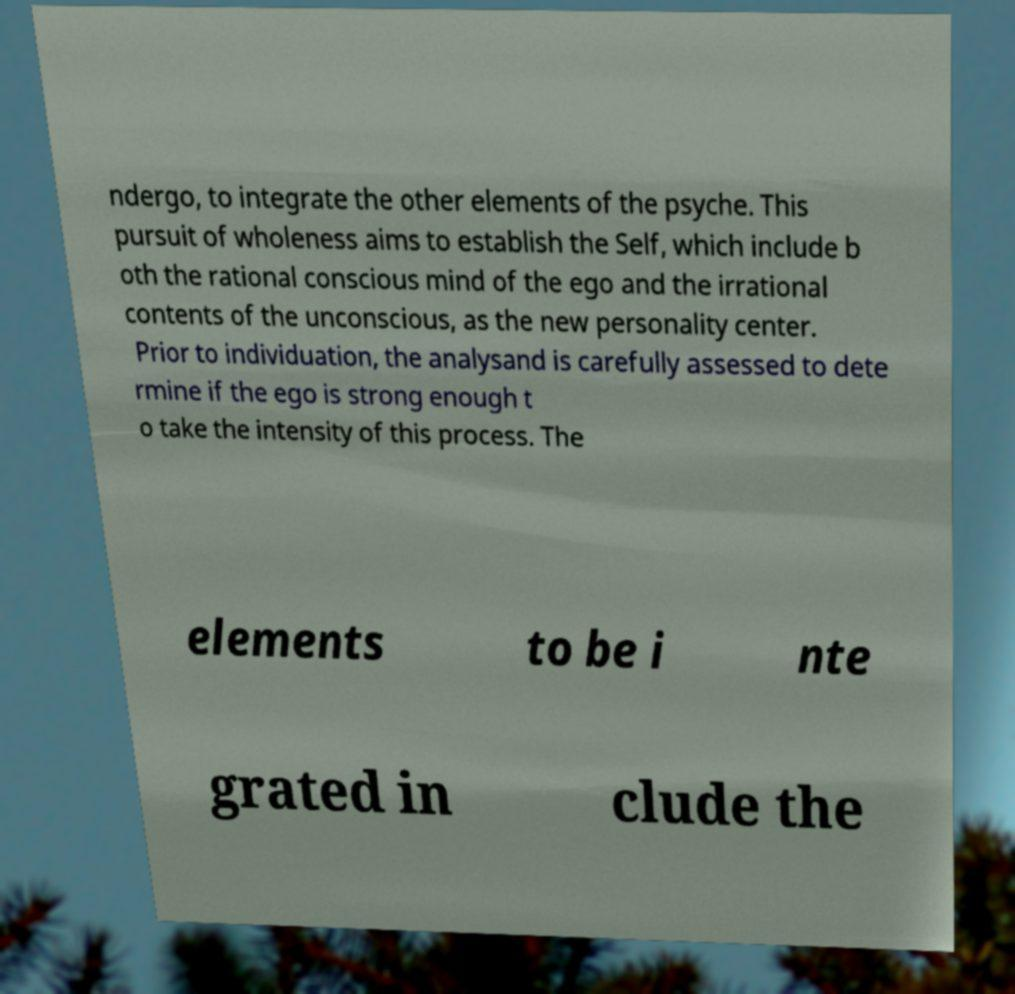Could you assist in decoding the text presented in this image and type it out clearly? ndergo, to integrate the other elements of the psyche. This pursuit of wholeness aims to establish the Self, which include b oth the rational conscious mind of the ego and the irrational contents of the unconscious, as the new personality center. Prior to individuation, the analysand is carefully assessed to dete rmine if the ego is strong enough t o take the intensity of this process. The elements to be i nte grated in clude the 